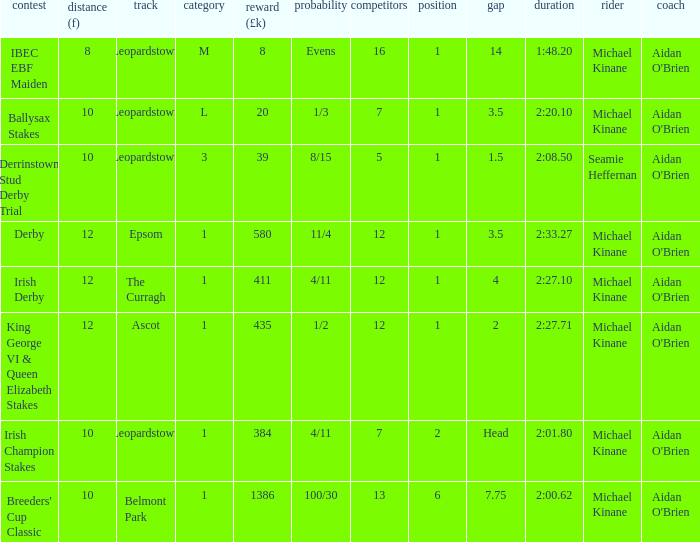Which Dist (f) has a Race of irish derby? 12.0. 